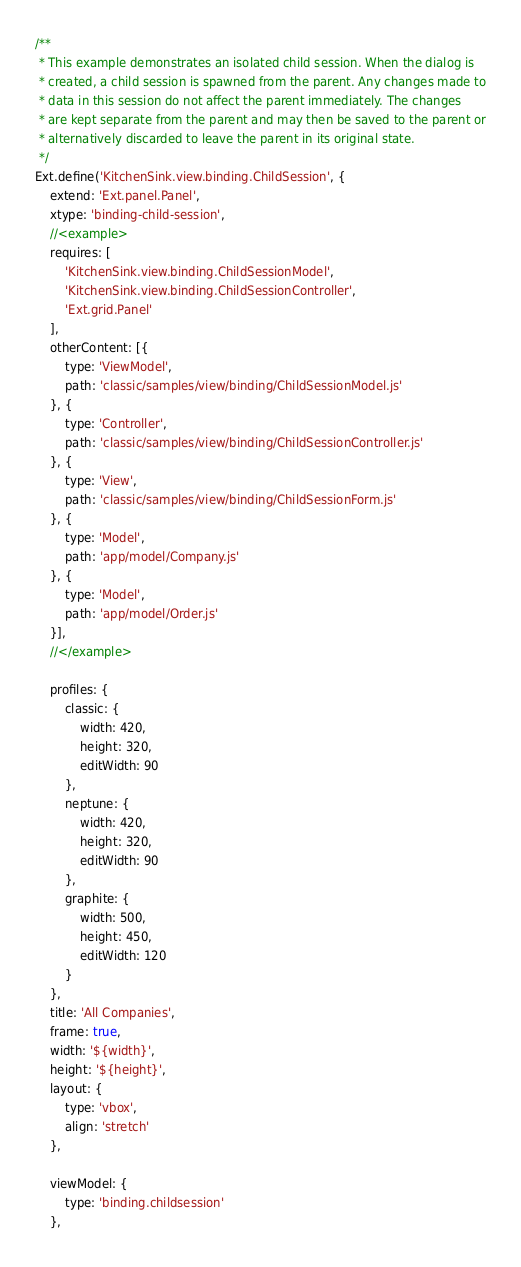<code> <loc_0><loc_0><loc_500><loc_500><_JavaScript_>/**
 * This example demonstrates an isolated child session. When the dialog is
 * created, a child session is spawned from the parent. Any changes made to
 * data in this session do not affect the parent immediately. The changes
 * are kept separate from the parent and may then be saved to the parent or
 * alternatively discarded to leave the parent in its original state.
 */
Ext.define('KitchenSink.view.binding.ChildSession', {
    extend: 'Ext.panel.Panel',
    xtype: 'binding-child-session',
    //<example>
    requires: [
        'KitchenSink.view.binding.ChildSessionModel',
        'KitchenSink.view.binding.ChildSessionController',
        'Ext.grid.Panel'
    ],
    otherContent: [{
        type: 'ViewModel',
        path: 'classic/samples/view/binding/ChildSessionModel.js'
    }, {
        type: 'Controller',
        path: 'classic/samples/view/binding/ChildSessionController.js'
    }, {
        type: 'View',
        path: 'classic/samples/view/binding/ChildSessionForm.js'
    }, {
        type: 'Model',
        path: 'app/model/Company.js'
    }, {
        type: 'Model',
        path: 'app/model/Order.js'
    }],
    //</example>

    profiles: {
        classic: {
            width: 420,
            height: 320,
            editWidth: 90
        },
        neptune: {
            width: 420,
            height: 320,
            editWidth: 90
        },
        graphite: {
            width: 500,
            height: 450,
            editWidth: 120
        }
    },
    title: 'All Companies',
    frame: true,
    width: '${width}',
    height: '${height}',
    layout: {
        type: 'vbox',
        align: 'stretch'
    },

    viewModel: {
        type: 'binding.childsession'
    },
</code> 